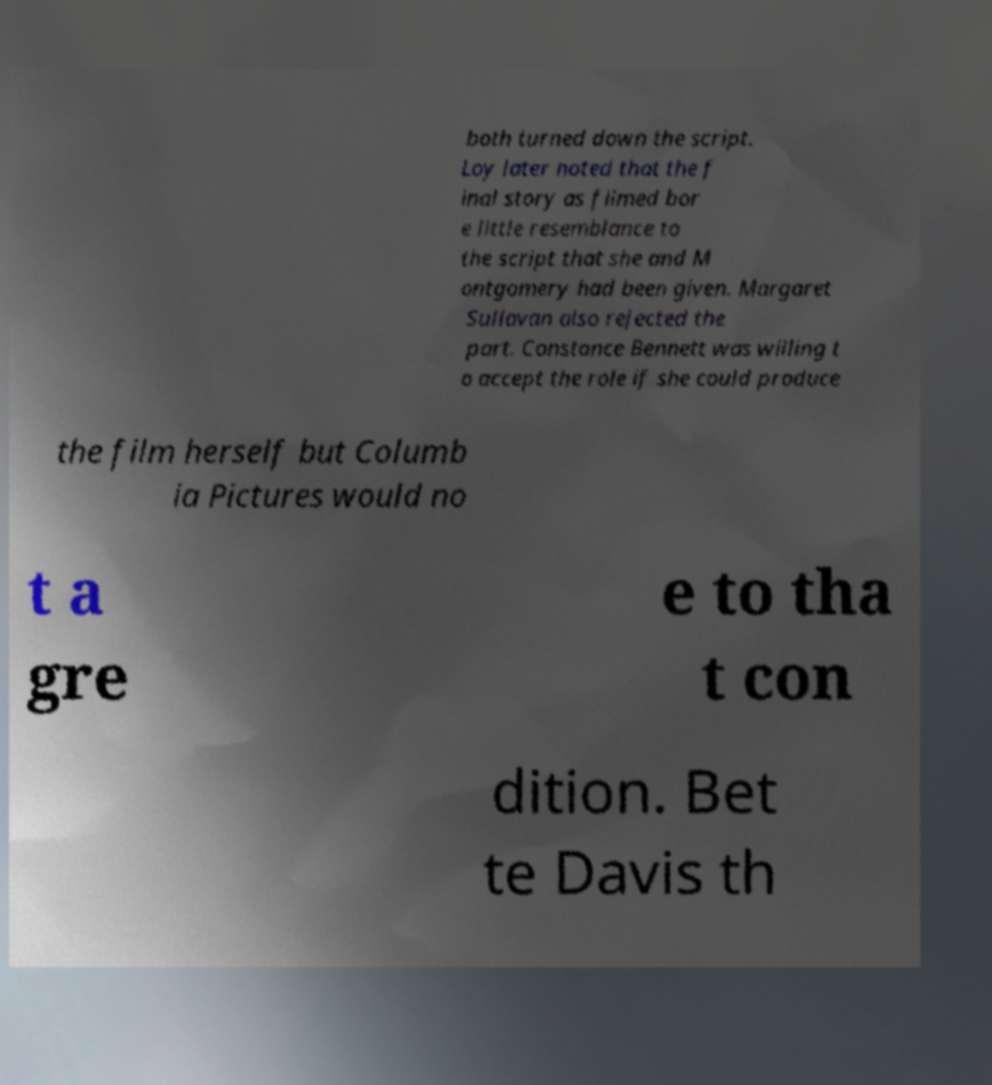Please identify and transcribe the text found in this image. both turned down the script. Loy later noted that the f inal story as filmed bor e little resemblance to the script that she and M ontgomery had been given. Margaret Sullavan also rejected the part. Constance Bennett was willing t o accept the role if she could produce the film herself but Columb ia Pictures would no t a gre e to tha t con dition. Bet te Davis th 